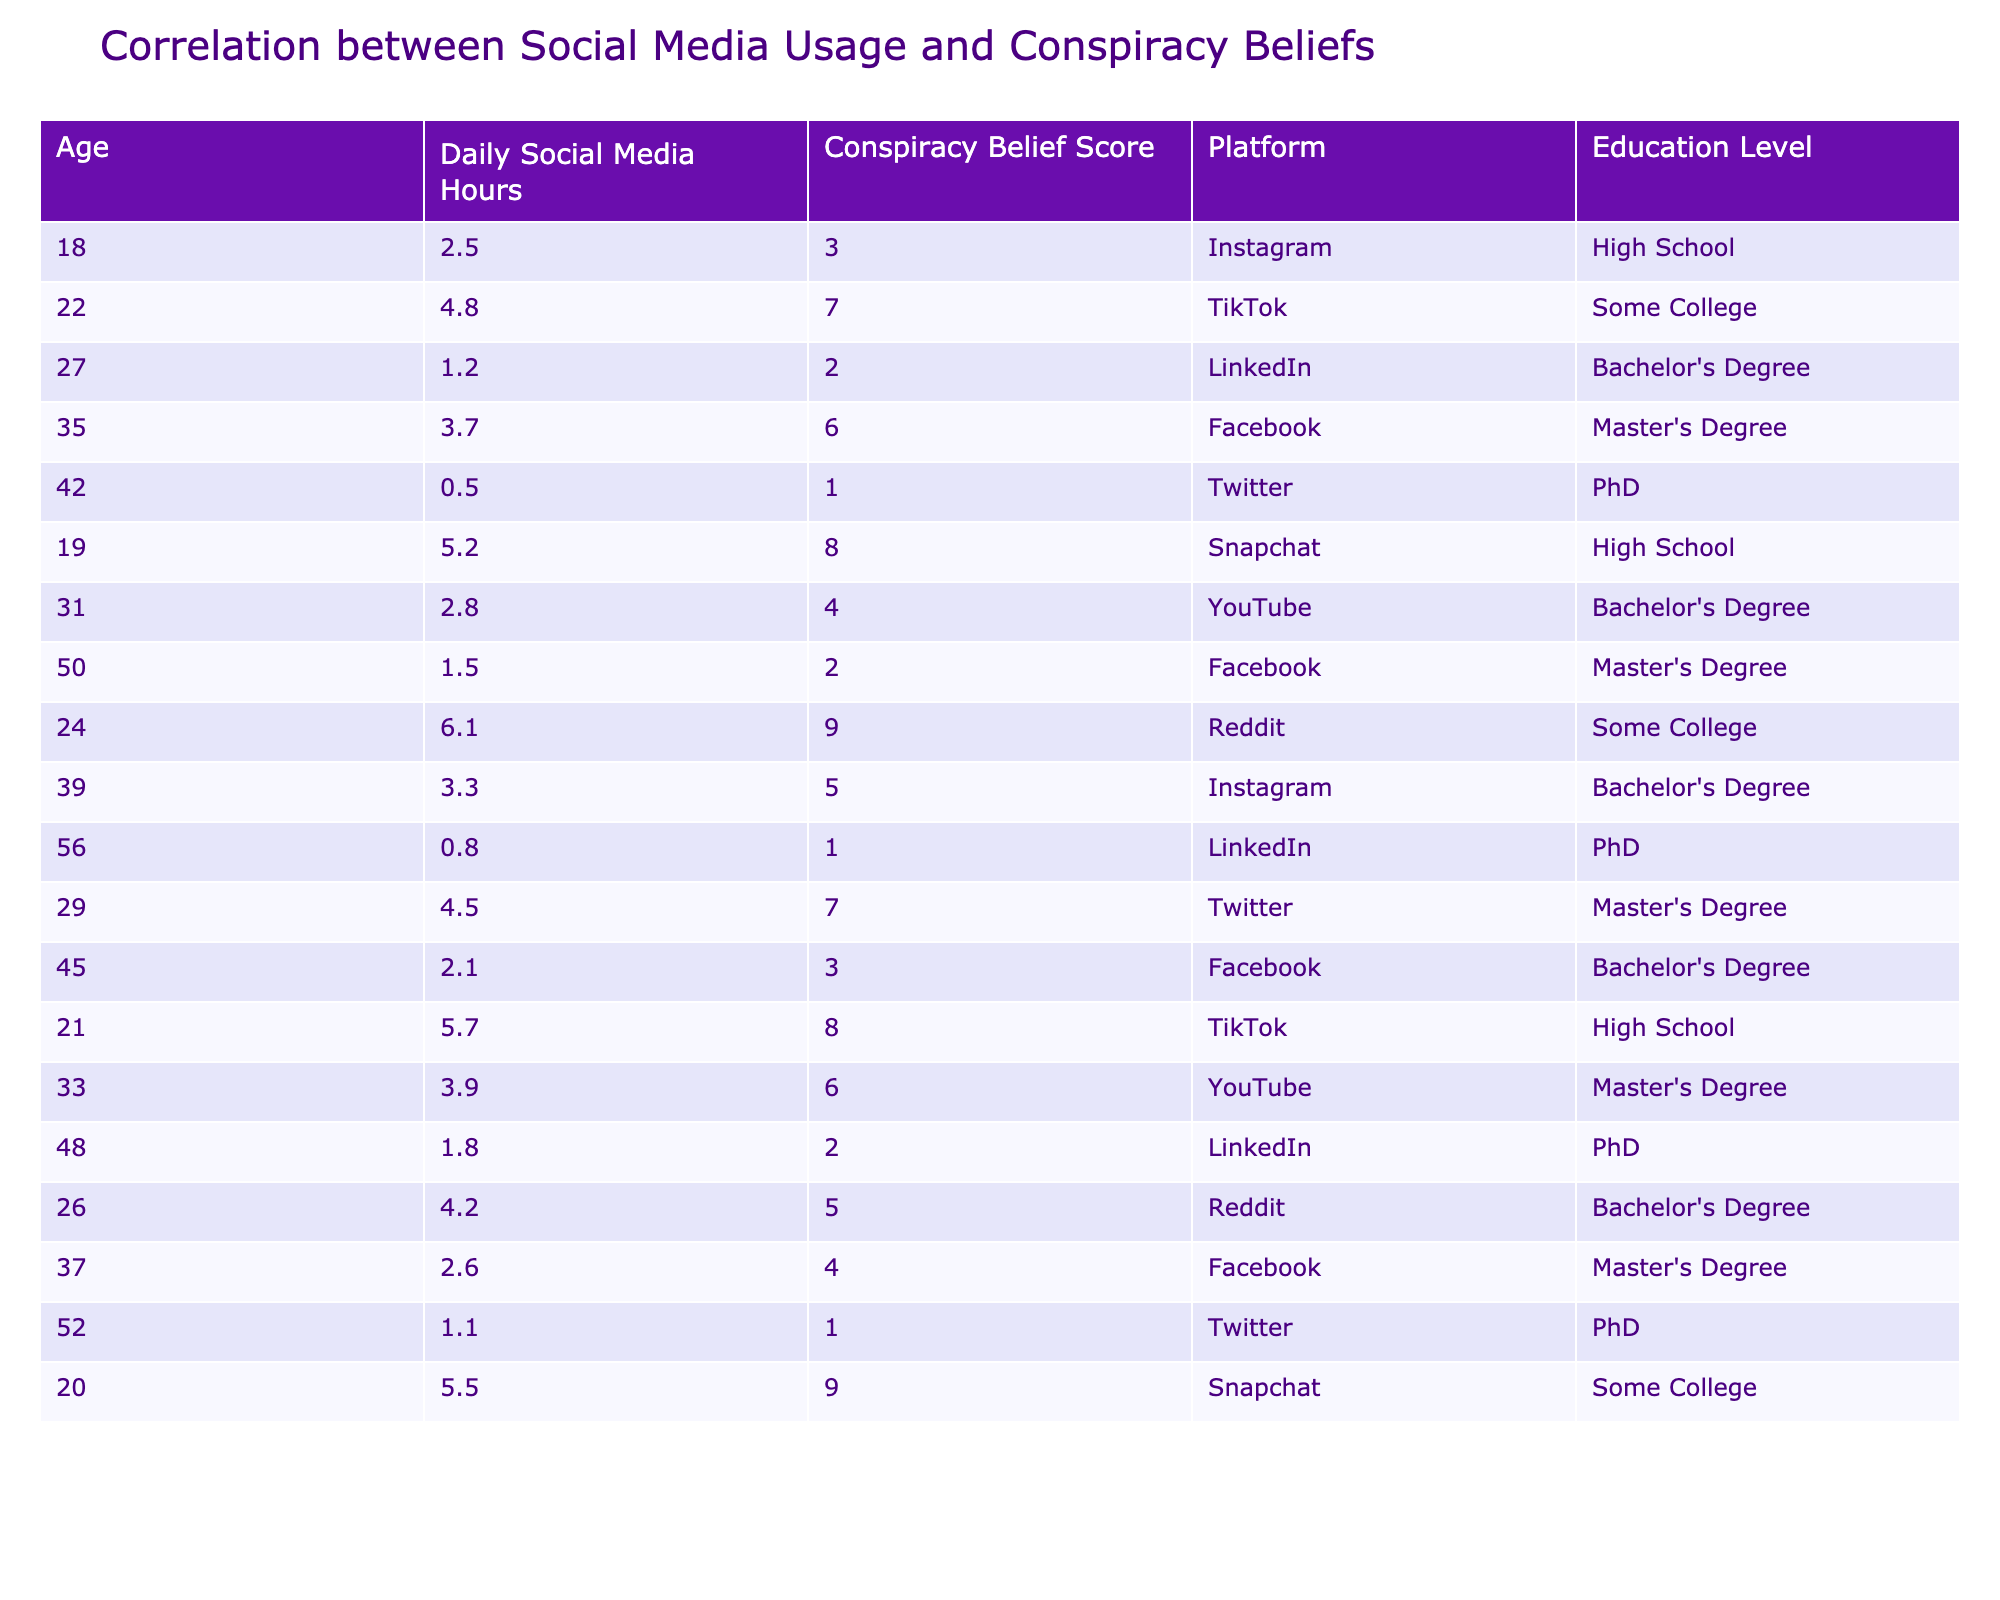What is the highest Conspiracy Belief Score in the table? By examining the "Conspiracy Belief Score" column, the highest value is 9, which corresponds to the entries of individuals who spend 6.1 hours and 5.5 hours on social media.
Answer: 9 What is the average time spent on social media by individuals with a Bachelor's Degree? We sum the values of "Daily Social Media Hours" for individuals with a Bachelor's Degree: (1.2 + 2.8 + 4.5 + 2.1 + 3.9 + 4.2) = 18.7. There are 6 individuals, so the average is 18.7 / 6 ≈ 3.12 hours.
Answer: 3.12 Is there any individual with a PhD who spends more than 4 hours on social media? Looking at the entries for individuals with PhDs, only those aged 42, 56, and 52 are considered, where 42 and 52 are below 4 hours, confirming there is no one above this threshold.
Answer: No What is the median Conspiracy Belief Score of individuals aged 18 to 30? First, isolate the scores for ages 18, 19, 20, 21, and 22, which are 3, 8, 9, 8, and 7 respectively. Sorting these gives us 3, 7, 8, 8, 9. The middle value (median) is 8.
Answer: 8 What is the correlation between time spent on social media and Conspiracy Belief Score for individuals aged 30 and above? For age 30 and above, record the hours and scores: (31, 4), (35, 6), (37, 4), (39, 5), (42, 1), (45, 3), (48, 2), (50, 2), and (56, 1). The data appears scattered, but scoring averages among higher hours point towards a lower belief score indicating a negative correlation. Confirming a precise correlation would require calculation, but it looks weak from observation.
Answer: Weak negative correlation What is the total Conspiracy Belief Score for users who primarily use Reddit? The table has two users that use Reddit, scoring 9 and 5. Adding these gives us 9 + 5 = 14.
Answer: 14 